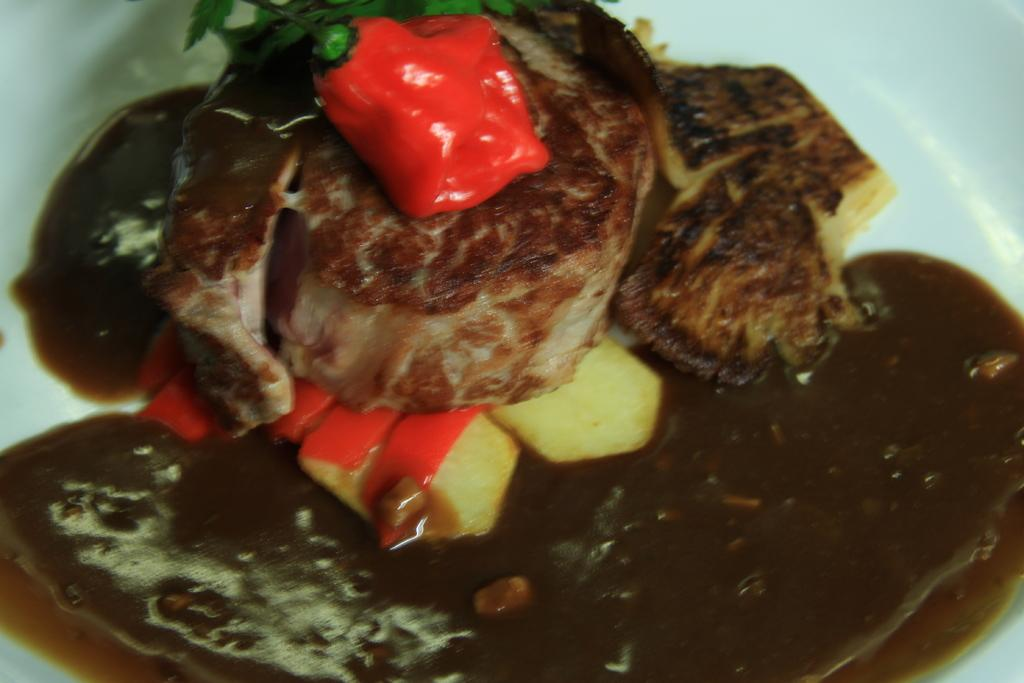What can be seen in the image in terms of food? There are different types of food in the image. Can you describe the colors of the food? The colors of the food are brown and black. How many trees are visible in the image? There are no trees visible in the image; it only shows different types of food with brown and black colors. 